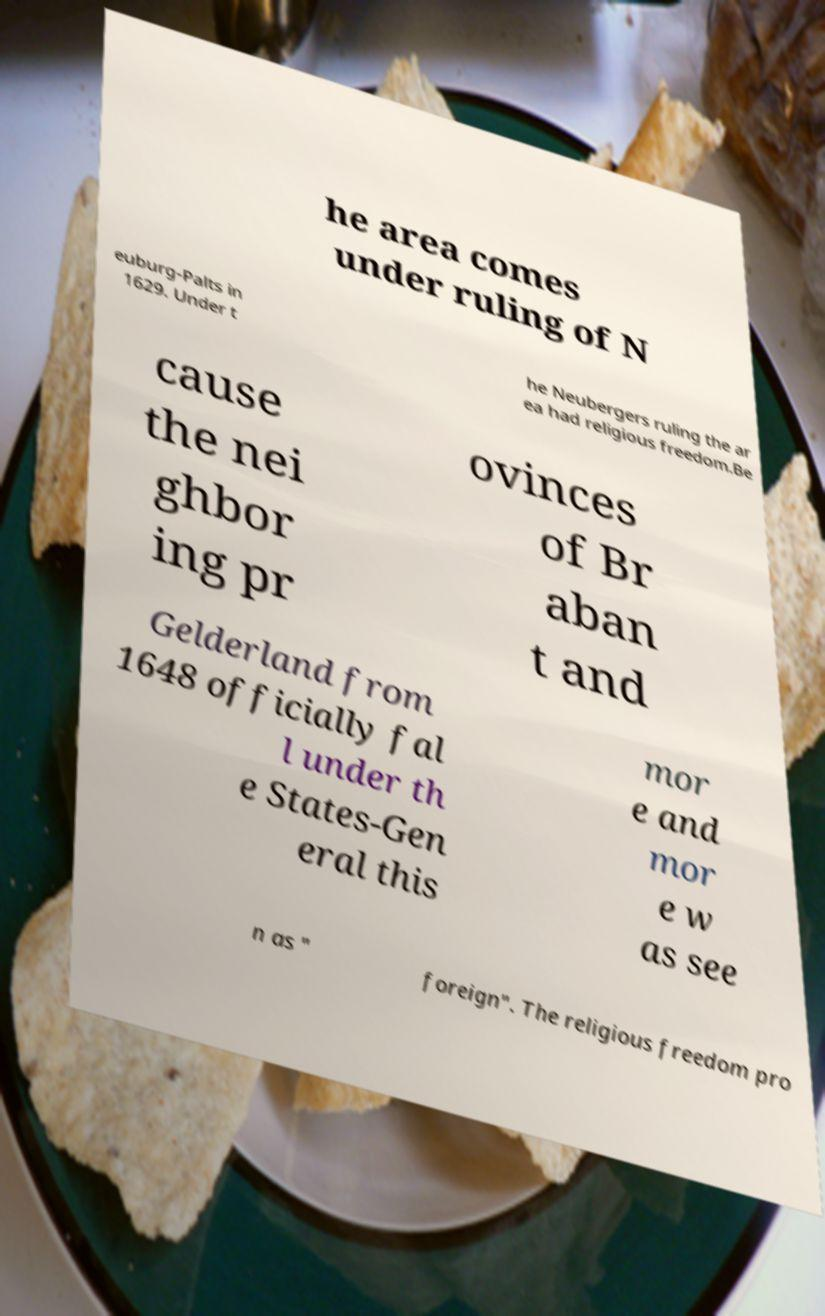Could you extract and type out the text from this image? he area comes under ruling of N euburg-Palts in 1629. Under t he Neubergers ruling the ar ea had religious freedom.Be cause the nei ghbor ing pr ovinces of Br aban t and Gelderland from 1648 officially fal l under th e States-Gen eral this mor e and mor e w as see n as " foreign". The religious freedom pro 